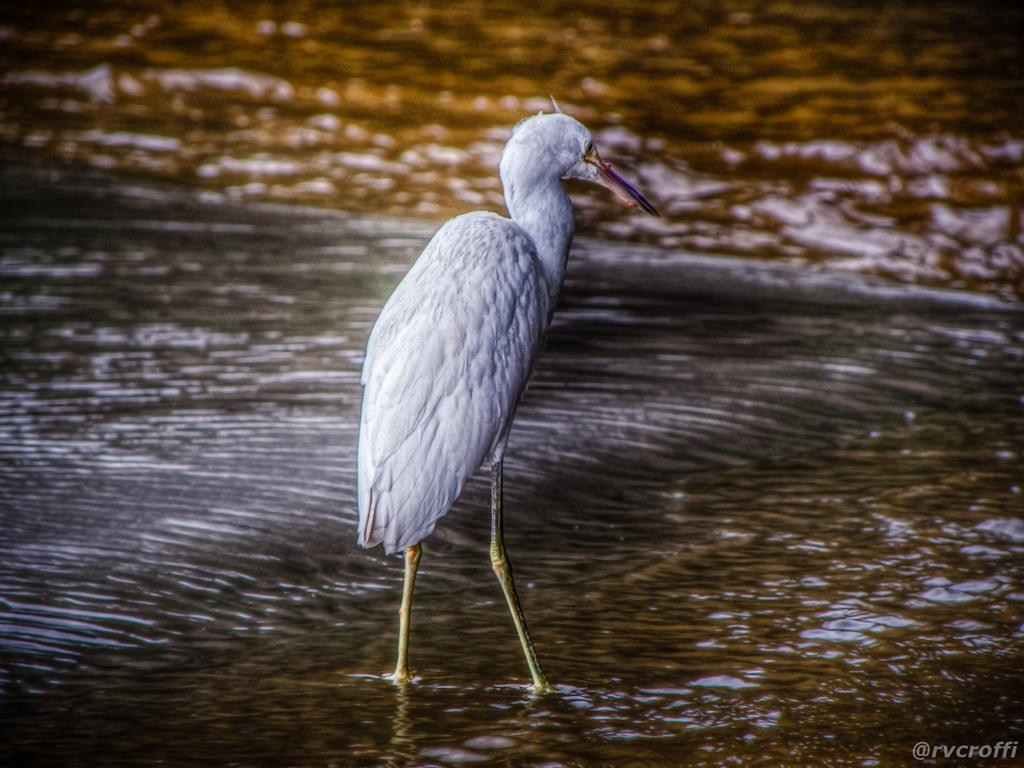What type of animal can be seen in the image? There is a white color bird in the image. Where is the bird located in the image? The bird is standing on the water. Is there any additional marking on the image? Yes, there is a watermark on the image. What type of pen is the bird holding in the image? There is no pen present in the image; the bird is standing on the water. Can you see a dog in the image? No, there is no dog present in the image; it features a white color bird standing on the water. 